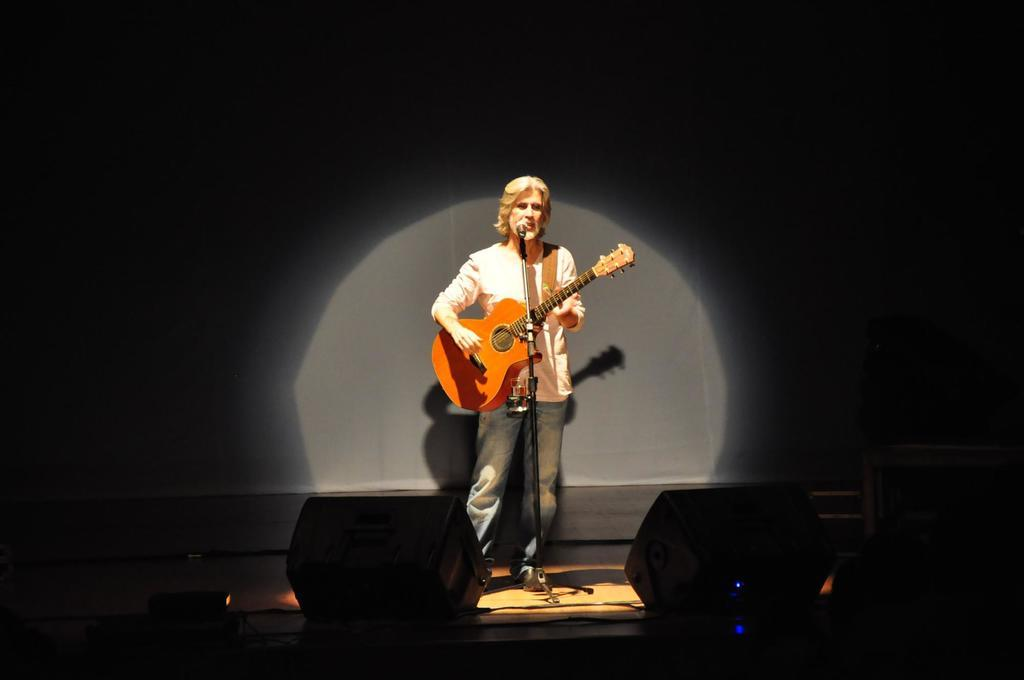Who is the main subject in the image? There is a person in the image. What is the person doing in the image? The person is playing a guitar. What object is in front of the person? There is a microphone in front of the person. How many children are playing on the team in the image? There are no children or teams present in the image; it features a person playing a guitar with a microphone in front of them. 